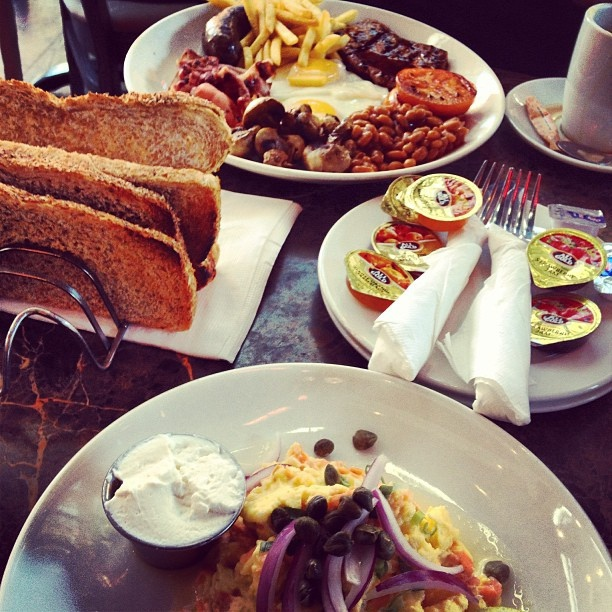Describe the objects in this image and their specific colors. I can see dining table in black, beige, maroon, and darkgray tones, bowl in black, beige, and darkgray tones, sandwich in black, brown, and tan tones, cup in black, brown, darkgray, gray, and beige tones, and fork in black, darkgray, gray, ivory, and maroon tones in this image. 